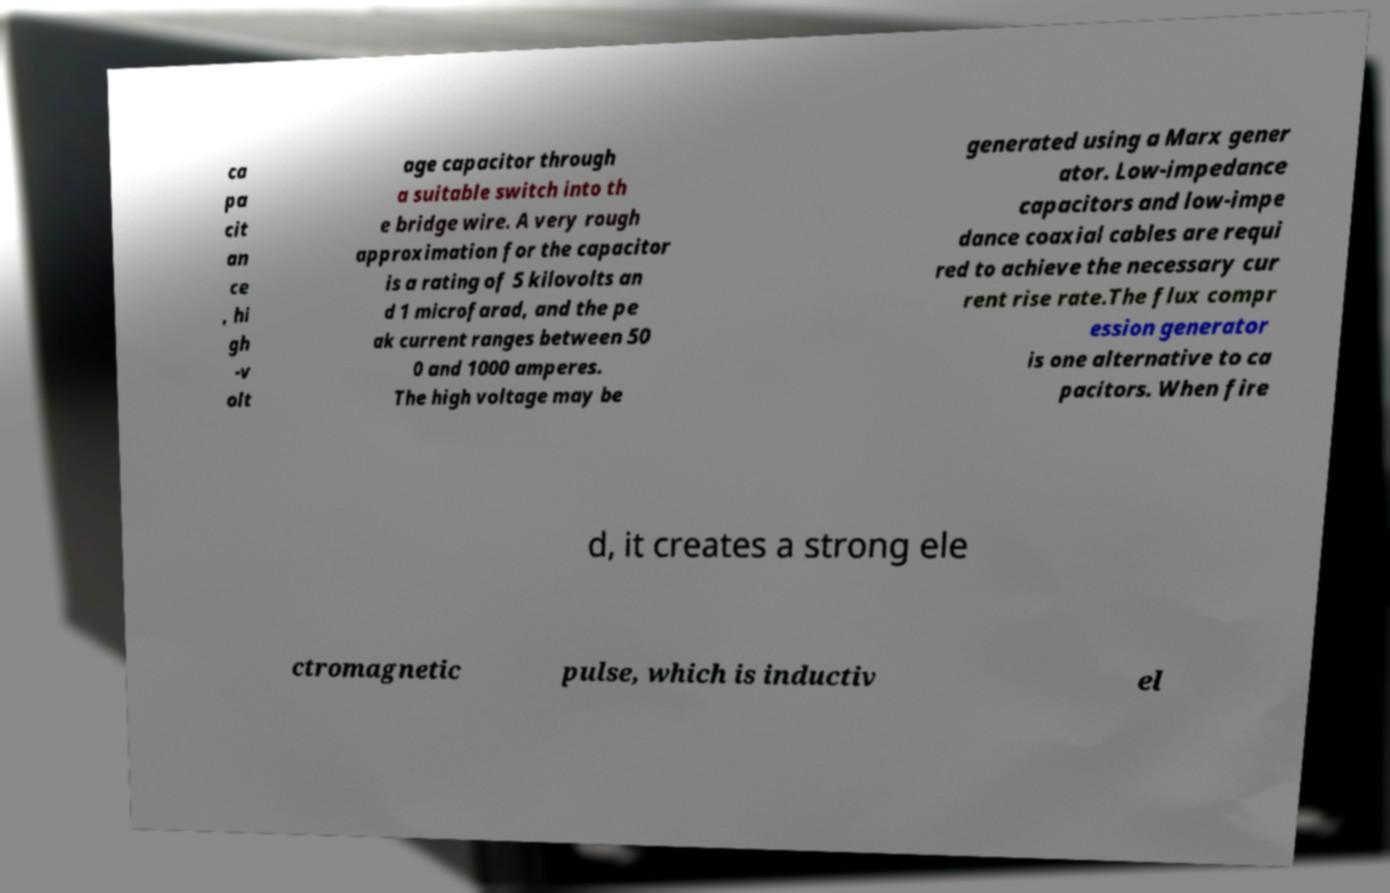Can you accurately transcribe the text from the provided image for me? ca pa cit an ce , hi gh -v olt age capacitor through a suitable switch into th e bridge wire. A very rough approximation for the capacitor is a rating of 5 kilovolts an d 1 microfarad, and the pe ak current ranges between 50 0 and 1000 amperes. The high voltage may be generated using a Marx gener ator. Low-impedance capacitors and low-impe dance coaxial cables are requi red to achieve the necessary cur rent rise rate.The flux compr ession generator is one alternative to ca pacitors. When fire d, it creates a strong ele ctromagnetic pulse, which is inductiv el 